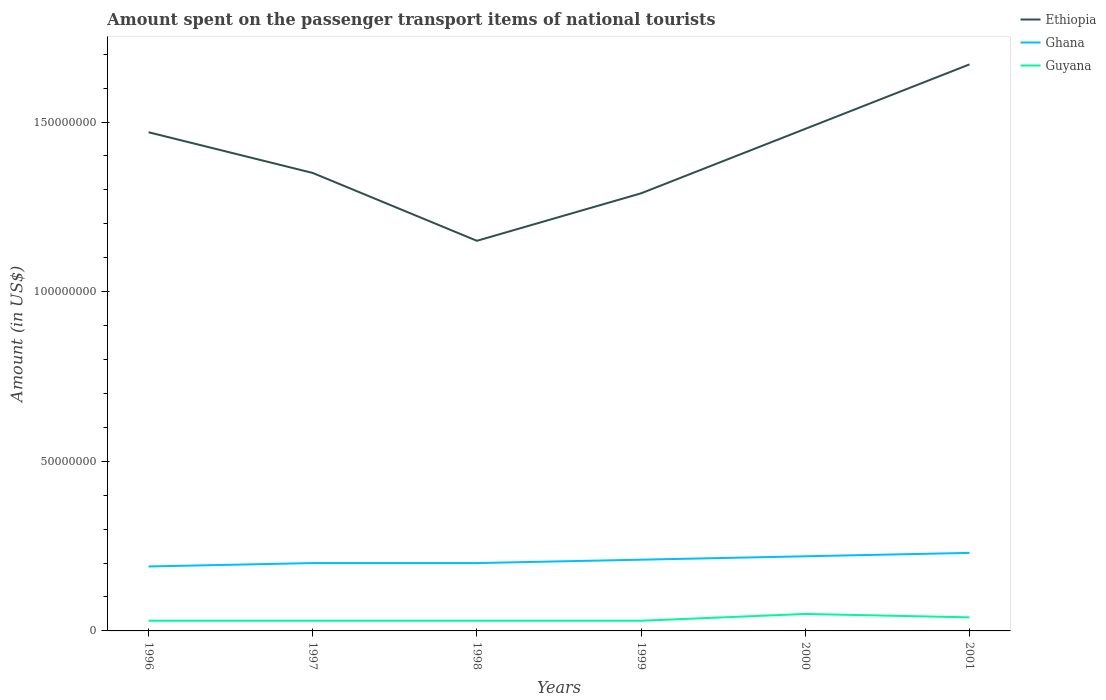Does the line corresponding to Ghana intersect with the line corresponding to Guyana?
Your response must be concise. No. Is the number of lines equal to the number of legend labels?
Ensure brevity in your answer.  Yes. Across all years, what is the maximum amount spent on the passenger transport items of national tourists in Ghana?
Your answer should be compact. 1.90e+07. What is the total amount spent on the passenger transport items of national tourists in Ghana in the graph?
Ensure brevity in your answer.  0. What is the difference between the highest and the second highest amount spent on the passenger transport items of national tourists in Guyana?
Your answer should be compact. 2.00e+06. Is the amount spent on the passenger transport items of national tourists in Ghana strictly greater than the amount spent on the passenger transport items of national tourists in Guyana over the years?
Your answer should be very brief. No. How many years are there in the graph?
Your answer should be compact. 6. Does the graph contain any zero values?
Offer a terse response. No. What is the title of the graph?
Provide a succinct answer. Amount spent on the passenger transport items of national tourists. Does "Bangladesh" appear as one of the legend labels in the graph?
Provide a succinct answer. No. What is the Amount (in US$) in Ethiopia in 1996?
Provide a succinct answer. 1.47e+08. What is the Amount (in US$) in Ghana in 1996?
Give a very brief answer. 1.90e+07. What is the Amount (in US$) in Ethiopia in 1997?
Offer a terse response. 1.35e+08. What is the Amount (in US$) of Ghana in 1997?
Offer a very short reply. 2.00e+07. What is the Amount (in US$) in Guyana in 1997?
Your answer should be compact. 3.00e+06. What is the Amount (in US$) of Ethiopia in 1998?
Provide a succinct answer. 1.15e+08. What is the Amount (in US$) of Ghana in 1998?
Provide a short and direct response. 2.00e+07. What is the Amount (in US$) of Ethiopia in 1999?
Make the answer very short. 1.29e+08. What is the Amount (in US$) in Ghana in 1999?
Your answer should be compact. 2.10e+07. What is the Amount (in US$) in Ethiopia in 2000?
Provide a succinct answer. 1.48e+08. What is the Amount (in US$) of Ghana in 2000?
Keep it short and to the point. 2.20e+07. What is the Amount (in US$) of Guyana in 2000?
Make the answer very short. 5.00e+06. What is the Amount (in US$) of Ethiopia in 2001?
Your answer should be compact. 1.67e+08. What is the Amount (in US$) in Ghana in 2001?
Give a very brief answer. 2.30e+07. What is the Amount (in US$) in Guyana in 2001?
Give a very brief answer. 4.00e+06. Across all years, what is the maximum Amount (in US$) of Ethiopia?
Make the answer very short. 1.67e+08. Across all years, what is the maximum Amount (in US$) in Ghana?
Provide a short and direct response. 2.30e+07. Across all years, what is the minimum Amount (in US$) in Ethiopia?
Your answer should be very brief. 1.15e+08. Across all years, what is the minimum Amount (in US$) in Ghana?
Give a very brief answer. 1.90e+07. What is the total Amount (in US$) of Ethiopia in the graph?
Offer a very short reply. 8.41e+08. What is the total Amount (in US$) of Ghana in the graph?
Ensure brevity in your answer.  1.25e+08. What is the total Amount (in US$) in Guyana in the graph?
Keep it short and to the point. 2.10e+07. What is the difference between the Amount (in US$) in Guyana in 1996 and that in 1997?
Offer a terse response. 0. What is the difference between the Amount (in US$) in Ethiopia in 1996 and that in 1998?
Give a very brief answer. 3.20e+07. What is the difference between the Amount (in US$) in Ghana in 1996 and that in 1998?
Offer a terse response. -1.00e+06. What is the difference between the Amount (in US$) of Ethiopia in 1996 and that in 1999?
Offer a terse response. 1.80e+07. What is the difference between the Amount (in US$) in Ghana in 1996 and that in 1999?
Your answer should be compact. -2.00e+06. What is the difference between the Amount (in US$) of Ghana in 1996 and that in 2000?
Your answer should be very brief. -3.00e+06. What is the difference between the Amount (in US$) in Guyana in 1996 and that in 2000?
Keep it short and to the point. -2.00e+06. What is the difference between the Amount (in US$) in Ethiopia in 1996 and that in 2001?
Your answer should be compact. -2.00e+07. What is the difference between the Amount (in US$) in Guyana in 1996 and that in 2001?
Give a very brief answer. -1.00e+06. What is the difference between the Amount (in US$) of Ethiopia in 1997 and that in 1999?
Ensure brevity in your answer.  6.00e+06. What is the difference between the Amount (in US$) in Ghana in 1997 and that in 1999?
Provide a succinct answer. -1.00e+06. What is the difference between the Amount (in US$) in Guyana in 1997 and that in 1999?
Provide a short and direct response. 0. What is the difference between the Amount (in US$) in Ethiopia in 1997 and that in 2000?
Provide a short and direct response. -1.30e+07. What is the difference between the Amount (in US$) in Ghana in 1997 and that in 2000?
Your answer should be very brief. -2.00e+06. What is the difference between the Amount (in US$) in Guyana in 1997 and that in 2000?
Ensure brevity in your answer.  -2.00e+06. What is the difference between the Amount (in US$) of Ethiopia in 1997 and that in 2001?
Your answer should be very brief. -3.20e+07. What is the difference between the Amount (in US$) of Ghana in 1997 and that in 2001?
Provide a succinct answer. -3.00e+06. What is the difference between the Amount (in US$) in Guyana in 1997 and that in 2001?
Your answer should be compact. -1.00e+06. What is the difference between the Amount (in US$) in Ethiopia in 1998 and that in 1999?
Make the answer very short. -1.40e+07. What is the difference between the Amount (in US$) in Ethiopia in 1998 and that in 2000?
Give a very brief answer. -3.30e+07. What is the difference between the Amount (in US$) of Ghana in 1998 and that in 2000?
Make the answer very short. -2.00e+06. What is the difference between the Amount (in US$) of Ethiopia in 1998 and that in 2001?
Offer a very short reply. -5.20e+07. What is the difference between the Amount (in US$) of Ghana in 1998 and that in 2001?
Your answer should be very brief. -3.00e+06. What is the difference between the Amount (in US$) of Ethiopia in 1999 and that in 2000?
Your answer should be very brief. -1.90e+07. What is the difference between the Amount (in US$) of Ethiopia in 1999 and that in 2001?
Your response must be concise. -3.80e+07. What is the difference between the Amount (in US$) in Ethiopia in 2000 and that in 2001?
Your response must be concise. -1.90e+07. What is the difference between the Amount (in US$) in Guyana in 2000 and that in 2001?
Offer a terse response. 1.00e+06. What is the difference between the Amount (in US$) in Ethiopia in 1996 and the Amount (in US$) in Ghana in 1997?
Your answer should be compact. 1.27e+08. What is the difference between the Amount (in US$) in Ethiopia in 1996 and the Amount (in US$) in Guyana in 1997?
Your response must be concise. 1.44e+08. What is the difference between the Amount (in US$) in Ghana in 1996 and the Amount (in US$) in Guyana in 1997?
Give a very brief answer. 1.60e+07. What is the difference between the Amount (in US$) of Ethiopia in 1996 and the Amount (in US$) of Ghana in 1998?
Give a very brief answer. 1.27e+08. What is the difference between the Amount (in US$) in Ethiopia in 1996 and the Amount (in US$) in Guyana in 1998?
Make the answer very short. 1.44e+08. What is the difference between the Amount (in US$) in Ghana in 1996 and the Amount (in US$) in Guyana in 1998?
Ensure brevity in your answer.  1.60e+07. What is the difference between the Amount (in US$) of Ethiopia in 1996 and the Amount (in US$) of Ghana in 1999?
Your answer should be compact. 1.26e+08. What is the difference between the Amount (in US$) of Ethiopia in 1996 and the Amount (in US$) of Guyana in 1999?
Provide a short and direct response. 1.44e+08. What is the difference between the Amount (in US$) in Ghana in 1996 and the Amount (in US$) in Guyana in 1999?
Offer a terse response. 1.60e+07. What is the difference between the Amount (in US$) in Ethiopia in 1996 and the Amount (in US$) in Ghana in 2000?
Offer a very short reply. 1.25e+08. What is the difference between the Amount (in US$) of Ethiopia in 1996 and the Amount (in US$) of Guyana in 2000?
Give a very brief answer. 1.42e+08. What is the difference between the Amount (in US$) of Ghana in 1996 and the Amount (in US$) of Guyana in 2000?
Ensure brevity in your answer.  1.40e+07. What is the difference between the Amount (in US$) of Ethiopia in 1996 and the Amount (in US$) of Ghana in 2001?
Your response must be concise. 1.24e+08. What is the difference between the Amount (in US$) in Ethiopia in 1996 and the Amount (in US$) in Guyana in 2001?
Provide a short and direct response. 1.43e+08. What is the difference between the Amount (in US$) in Ghana in 1996 and the Amount (in US$) in Guyana in 2001?
Your answer should be very brief. 1.50e+07. What is the difference between the Amount (in US$) of Ethiopia in 1997 and the Amount (in US$) of Ghana in 1998?
Your response must be concise. 1.15e+08. What is the difference between the Amount (in US$) of Ethiopia in 1997 and the Amount (in US$) of Guyana in 1998?
Your answer should be very brief. 1.32e+08. What is the difference between the Amount (in US$) in Ghana in 1997 and the Amount (in US$) in Guyana in 1998?
Offer a terse response. 1.70e+07. What is the difference between the Amount (in US$) of Ethiopia in 1997 and the Amount (in US$) of Ghana in 1999?
Make the answer very short. 1.14e+08. What is the difference between the Amount (in US$) of Ethiopia in 1997 and the Amount (in US$) of Guyana in 1999?
Ensure brevity in your answer.  1.32e+08. What is the difference between the Amount (in US$) in Ghana in 1997 and the Amount (in US$) in Guyana in 1999?
Make the answer very short. 1.70e+07. What is the difference between the Amount (in US$) in Ethiopia in 1997 and the Amount (in US$) in Ghana in 2000?
Offer a very short reply. 1.13e+08. What is the difference between the Amount (in US$) in Ethiopia in 1997 and the Amount (in US$) in Guyana in 2000?
Ensure brevity in your answer.  1.30e+08. What is the difference between the Amount (in US$) in Ghana in 1997 and the Amount (in US$) in Guyana in 2000?
Make the answer very short. 1.50e+07. What is the difference between the Amount (in US$) of Ethiopia in 1997 and the Amount (in US$) of Ghana in 2001?
Your answer should be compact. 1.12e+08. What is the difference between the Amount (in US$) of Ethiopia in 1997 and the Amount (in US$) of Guyana in 2001?
Make the answer very short. 1.31e+08. What is the difference between the Amount (in US$) in Ghana in 1997 and the Amount (in US$) in Guyana in 2001?
Keep it short and to the point. 1.60e+07. What is the difference between the Amount (in US$) of Ethiopia in 1998 and the Amount (in US$) of Ghana in 1999?
Give a very brief answer. 9.40e+07. What is the difference between the Amount (in US$) in Ethiopia in 1998 and the Amount (in US$) in Guyana in 1999?
Give a very brief answer. 1.12e+08. What is the difference between the Amount (in US$) of Ghana in 1998 and the Amount (in US$) of Guyana in 1999?
Offer a very short reply. 1.70e+07. What is the difference between the Amount (in US$) of Ethiopia in 1998 and the Amount (in US$) of Ghana in 2000?
Provide a short and direct response. 9.30e+07. What is the difference between the Amount (in US$) of Ethiopia in 1998 and the Amount (in US$) of Guyana in 2000?
Ensure brevity in your answer.  1.10e+08. What is the difference between the Amount (in US$) in Ghana in 1998 and the Amount (in US$) in Guyana in 2000?
Your response must be concise. 1.50e+07. What is the difference between the Amount (in US$) in Ethiopia in 1998 and the Amount (in US$) in Ghana in 2001?
Offer a very short reply. 9.20e+07. What is the difference between the Amount (in US$) in Ethiopia in 1998 and the Amount (in US$) in Guyana in 2001?
Make the answer very short. 1.11e+08. What is the difference between the Amount (in US$) in Ghana in 1998 and the Amount (in US$) in Guyana in 2001?
Give a very brief answer. 1.60e+07. What is the difference between the Amount (in US$) of Ethiopia in 1999 and the Amount (in US$) of Ghana in 2000?
Your answer should be compact. 1.07e+08. What is the difference between the Amount (in US$) in Ethiopia in 1999 and the Amount (in US$) in Guyana in 2000?
Your answer should be compact. 1.24e+08. What is the difference between the Amount (in US$) in Ghana in 1999 and the Amount (in US$) in Guyana in 2000?
Ensure brevity in your answer.  1.60e+07. What is the difference between the Amount (in US$) of Ethiopia in 1999 and the Amount (in US$) of Ghana in 2001?
Your response must be concise. 1.06e+08. What is the difference between the Amount (in US$) in Ethiopia in 1999 and the Amount (in US$) in Guyana in 2001?
Keep it short and to the point. 1.25e+08. What is the difference between the Amount (in US$) of Ghana in 1999 and the Amount (in US$) of Guyana in 2001?
Provide a short and direct response. 1.70e+07. What is the difference between the Amount (in US$) of Ethiopia in 2000 and the Amount (in US$) of Ghana in 2001?
Offer a very short reply. 1.25e+08. What is the difference between the Amount (in US$) in Ethiopia in 2000 and the Amount (in US$) in Guyana in 2001?
Your answer should be very brief. 1.44e+08. What is the difference between the Amount (in US$) in Ghana in 2000 and the Amount (in US$) in Guyana in 2001?
Your answer should be compact. 1.80e+07. What is the average Amount (in US$) in Ethiopia per year?
Provide a short and direct response. 1.40e+08. What is the average Amount (in US$) in Ghana per year?
Your answer should be compact. 2.08e+07. What is the average Amount (in US$) in Guyana per year?
Ensure brevity in your answer.  3.50e+06. In the year 1996, what is the difference between the Amount (in US$) of Ethiopia and Amount (in US$) of Ghana?
Make the answer very short. 1.28e+08. In the year 1996, what is the difference between the Amount (in US$) in Ethiopia and Amount (in US$) in Guyana?
Offer a very short reply. 1.44e+08. In the year 1996, what is the difference between the Amount (in US$) in Ghana and Amount (in US$) in Guyana?
Your response must be concise. 1.60e+07. In the year 1997, what is the difference between the Amount (in US$) in Ethiopia and Amount (in US$) in Ghana?
Your answer should be very brief. 1.15e+08. In the year 1997, what is the difference between the Amount (in US$) in Ethiopia and Amount (in US$) in Guyana?
Your answer should be compact. 1.32e+08. In the year 1997, what is the difference between the Amount (in US$) of Ghana and Amount (in US$) of Guyana?
Your response must be concise. 1.70e+07. In the year 1998, what is the difference between the Amount (in US$) in Ethiopia and Amount (in US$) in Ghana?
Provide a succinct answer. 9.50e+07. In the year 1998, what is the difference between the Amount (in US$) of Ethiopia and Amount (in US$) of Guyana?
Make the answer very short. 1.12e+08. In the year 1998, what is the difference between the Amount (in US$) in Ghana and Amount (in US$) in Guyana?
Your answer should be compact. 1.70e+07. In the year 1999, what is the difference between the Amount (in US$) in Ethiopia and Amount (in US$) in Ghana?
Offer a terse response. 1.08e+08. In the year 1999, what is the difference between the Amount (in US$) of Ethiopia and Amount (in US$) of Guyana?
Offer a very short reply. 1.26e+08. In the year 1999, what is the difference between the Amount (in US$) in Ghana and Amount (in US$) in Guyana?
Give a very brief answer. 1.80e+07. In the year 2000, what is the difference between the Amount (in US$) of Ethiopia and Amount (in US$) of Ghana?
Offer a very short reply. 1.26e+08. In the year 2000, what is the difference between the Amount (in US$) in Ethiopia and Amount (in US$) in Guyana?
Your response must be concise. 1.43e+08. In the year 2000, what is the difference between the Amount (in US$) of Ghana and Amount (in US$) of Guyana?
Offer a very short reply. 1.70e+07. In the year 2001, what is the difference between the Amount (in US$) in Ethiopia and Amount (in US$) in Ghana?
Offer a very short reply. 1.44e+08. In the year 2001, what is the difference between the Amount (in US$) in Ethiopia and Amount (in US$) in Guyana?
Make the answer very short. 1.63e+08. In the year 2001, what is the difference between the Amount (in US$) in Ghana and Amount (in US$) in Guyana?
Your answer should be very brief. 1.90e+07. What is the ratio of the Amount (in US$) in Ethiopia in 1996 to that in 1997?
Your response must be concise. 1.09. What is the ratio of the Amount (in US$) in Ghana in 1996 to that in 1997?
Offer a very short reply. 0.95. What is the ratio of the Amount (in US$) of Guyana in 1996 to that in 1997?
Provide a short and direct response. 1. What is the ratio of the Amount (in US$) of Ethiopia in 1996 to that in 1998?
Provide a succinct answer. 1.28. What is the ratio of the Amount (in US$) in Ghana in 1996 to that in 1998?
Provide a succinct answer. 0.95. What is the ratio of the Amount (in US$) in Guyana in 1996 to that in 1998?
Offer a very short reply. 1. What is the ratio of the Amount (in US$) in Ethiopia in 1996 to that in 1999?
Keep it short and to the point. 1.14. What is the ratio of the Amount (in US$) of Ghana in 1996 to that in 1999?
Provide a succinct answer. 0.9. What is the ratio of the Amount (in US$) of Ghana in 1996 to that in 2000?
Your answer should be very brief. 0.86. What is the ratio of the Amount (in US$) in Guyana in 1996 to that in 2000?
Provide a succinct answer. 0.6. What is the ratio of the Amount (in US$) of Ethiopia in 1996 to that in 2001?
Make the answer very short. 0.88. What is the ratio of the Amount (in US$) of Ghana in 1996 to that in 2001?
Your answer should be compact. 0.83. What is the ratio of the Amount (in US$) in Ethiopia in 1997 to that in 1998?
Provide a short and direct response. 1.17. What is the ratio of the Amount (in US$) of Ghana in 1997 to that in 1998?
Provide a succinct answer. 1. What is the ratio of the Amount (in US$) in Guyana in 1997 to that in 1998?
Your answer should be compact. 1. What is the ratio of the Amount (in US$) of Ethiopia in 1997 to that in 1999?
Keep it short and to the point. 1.05. What is the ratio of the Amount (in US$) of Ethiopia in 1997 to that in 2000?
Provide a short and direct response. 0.91. What is the ratio of the Amount (in US$) in Ethiopia in 1997 to that in 2001?
Keep it short and to the point. 0.81. What is the ratio of the Amount (in US$) of Ghana in 1997 to that in 2001?
Your answer should be very brief. 0.87. What is the ratio of the Amount (in US$) in Guyana in 1997 to that in 2001?
Offer a very short reply. 0.75. What is the ratio of the Amount (in US$) in Ethiopia in 1998 to that in 1999?
Offer a terse response. 0.89. What is the ratio of the Amount (in US$) of Guyana in 1998 to that in 1999?
Keep it short and to the point. 1. What is the ratio of the Amount (in US$) of Ethiopia in 1998 to that in 2000?
Provide a short and direct response. 0.78. What is the ratio of the Amount (in US$) in Ethiopia in 1998 to that in 2001?
Give a very brief answer. 0.69. What is the ratio of the Amount (in US$) in Ghana in 1998 to that in 2001?
Your response must be concise. 0.87. What is the ratio of the Amount (in US$) of Guyana in 1998 to that in 2001?
Your response must be concise. 0.75. What is the ratio of the Amount (in US$) of Ethiopia in 1999 to that in 2000?
Give a very brief answer. 0.87. What is the ratio of the Amount (in US$) of Ghana in 1999 to that in 2000?
Give a very brief answer. 0.95. What is the ratio of the Amount (in US$) in Guyana in 1999 to that in 2000?
Your response must be concise. 0.6. What is the ratio of the Amount (in US$) of Ethiopia in 1999 to that in 2001?
Offer a terse response. 0.77. What is the ratio of the Amount (in US$) in Ghana in 1999 to that in 2001?
Provide a succinct answer. 0.91. What is the ratio of the Amount (in US$) in Ethiopia in 2000 to that in 2001?
Make the answer very short. 0.89. What is the ratio of the Amount (in US$) of Ghana in 2000 to that in 2001?
Your response must be concise. 0.96. What is the ratio of the Amount (in US$) in Guyana in 2000 to that in 2001?
Provide a short and direct response. 1.25. What is the difference between the highest and the second highest Amount (in US$) of Ethiopia?
Your response must be concise. 1.90e+07. What is the difference between the highest and the second highest Amount (in US$) in Ghana?
Ensure brevity in your answer.  1.00e+06. What is the difference between the highest and the second highest Amount (in US$) in Guyana?
Your answer should be very brief. 1.00e+06. What is the difference between the highest and the lowest Amount (in US$) of Ethiopia?
Offer a very short reply. 5.20e+07. What is the difference between the highest and the lowest Amount (in US$) in Guyana?
Your answer should be very brief. 2.00e+06. 